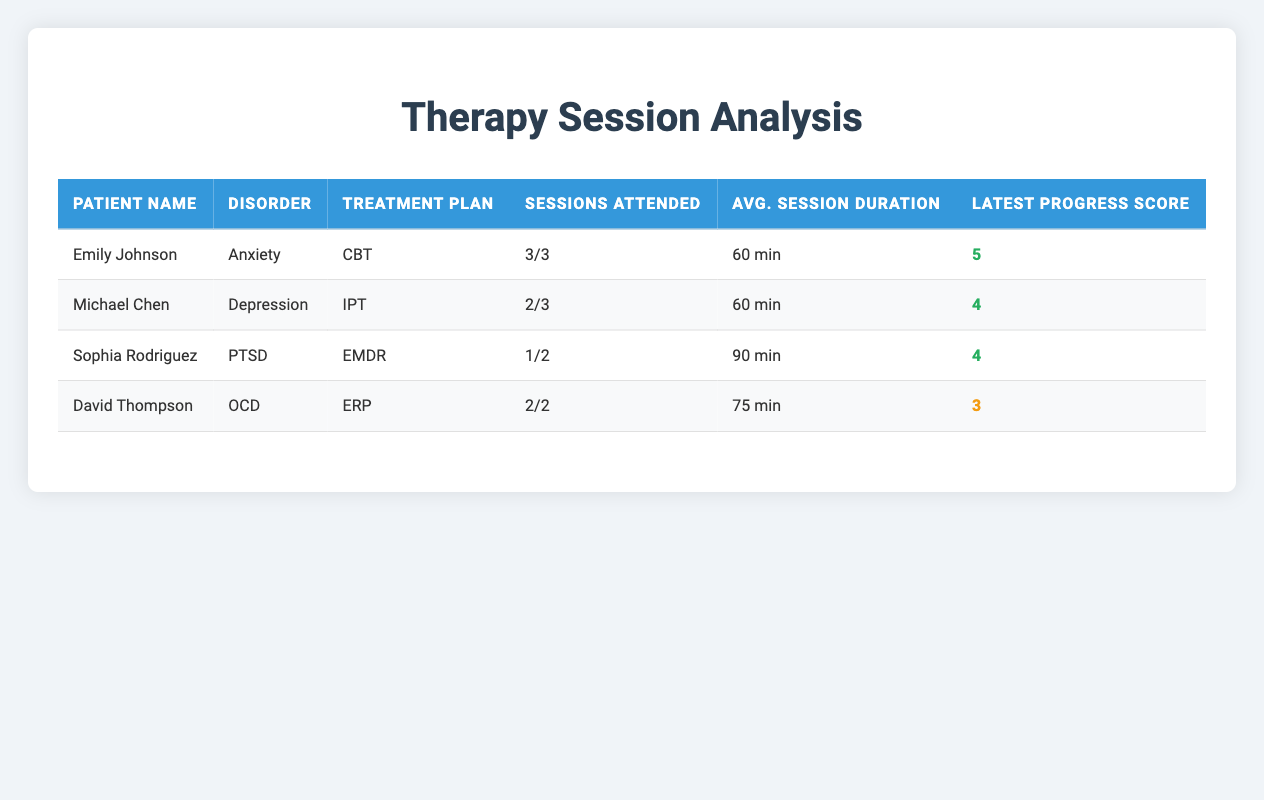What is the average session duration for David Thompson? David Thompson has attended 2 sessions, each having a duration of 75 minutes. Therefore, the average session duration is simply 75 minutes since both sessions have the same duration.
Answer: 75 min How many sessions did Sophia Rodriguez attend? Sophia Rodriguez attended 1 out of 2 scheduled sessions, so this is reflected in the "Sessions Attended" column under her name.
Answer: 1/2 Did Emily Johnson attend all of her sessions? Emily Johnson attended all her sessions, as indicated by the "Sessions Attended" which shows 3/3.
Answer: Yes What is the highest progress score recorded in the table? The highest individual progress score recorded in the table is 5, which is reflected in the progress score of Emily Johnson.
Answer: 5 How many total sessions were conducted for patients whose disorder is Anxiety? There were 3 sessions conducted for Emily Johnson, who has Anxiety. Since there is only one patient with this disorder in the data, the total is simply the sessions she attended.
Answer: 3 What was the total progress score obtained by Michael Chen? Michael Chen's progress scores are 2 (for the first session) and 4 (for the second session). Adding them together results in a total progress score of 6 (2 + 4 = 6).
Answer: 6 How many patients have a progress score of 4 or higher? The patients with progress scores of 4 or higher are Emily Johnson (5), Michael Chen (4), and Sophia Rodriguez (4). This totals to 3 patients.
Answer: 3 Has any patient missed more sessions than they attended? Yes, Sophia Rodriguez missed one session and only attended one session (1/2), indicating that she did not attend more sessions than she attended.
Answer: Yes What is the relationship between session attendance and progress score for the patients listed? Patients with perfect attendance generally have the highest progress scores. Emily Johnson, who attended all 3 sessions, has the highest progress score (5). Michael Chen, with 2 out of 3 sessions attended, has a progress score of 4. Conversely, Sophia Rodriguez, who missed a session, maintained a score of 4.
Answer: Higher attendance tends to correlate with higher progress scores 